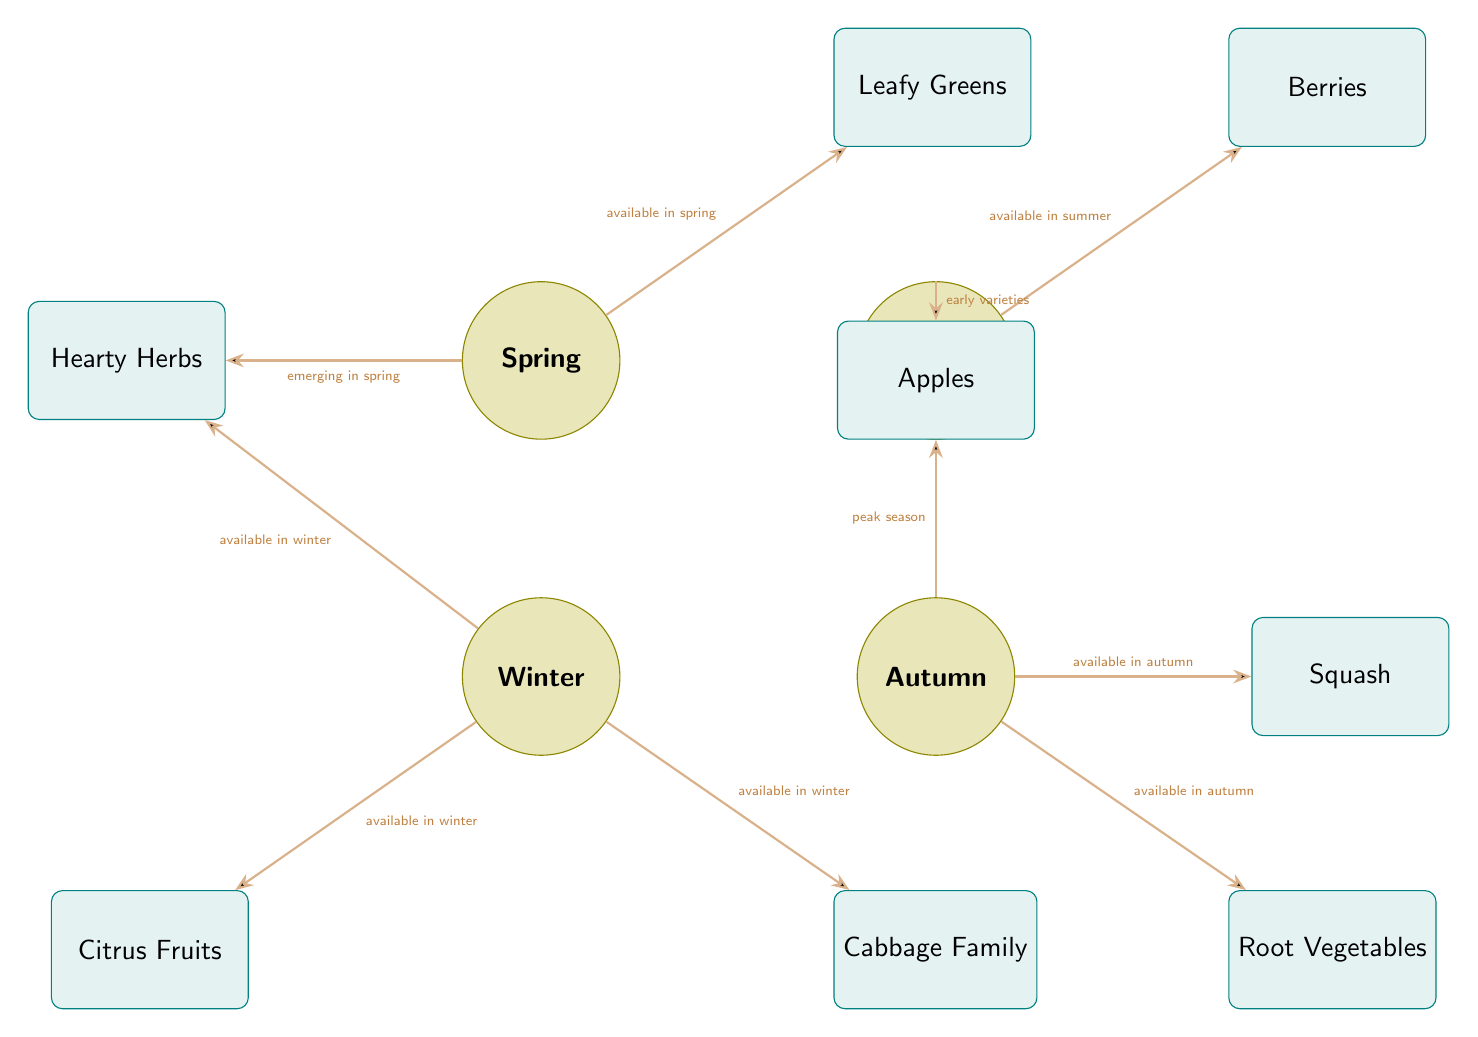What food is available in spring? The diagram shows the connection from the "Spring" node to the "Leafy Greens" food node, indicating that leafy greens are available in spring.
Answer: Leafy Greens Which food has its peak season in autumn? The diagram has a direct edge from the "Autumn" node to the "Apples" node stating "peak season". This indicates that apples have their peak season in autumn.
Answer: Apples What food is available during winter? The diagram shows the connections from the "Winter" node to both "Citrus Fruits" and "Cabbage Family" food nodes, indicating both are available during winter.
Answer: Citrus Fruits, Cabbage Family How many food types are available in summer? The diagram displays one food connection stemming from the "Summer" node to the "Berries" food node. Therefore, there is one food type available in summer.
Answer: 1 Which food is emerging in spring? The diagram includes a connection from the "Spring" node to the "Hearty Herbs" node labeled "emerging in spring", indicating that hearty herbs are emerging in spring.
Answer: Hearty Herbs Which food is categorized as a root vegetable, and when is it available? The diagram connects the "Autumn" node to the "Root Vegetables" food node, stating "available in autumn" which identifies root vegetables as being available in autumn.
Answer: Root Vegetables, Autumn How many seasons do leafy greens have availability? The diagram shows that leafy greens are connected only to the "Spring" node. Thus, they are available in one season—spring.
Answer: 1 Which food type is connected to the winter season, labeled as 'available in winter'? The "Citrus Fruits" and "Cabbage Family" food nodes both connect from the "Winter" node with the label "available in winter", thus identifying both food types.
Answer: Citrus Fruits, Cabbage Family What are the two types of food shown in autumn? The diagram connects "Autumn" to "Root Vegetables" and "Squash", indicating that both types of food are shown in autumn.
Answer: Root Vegetables, Squash 